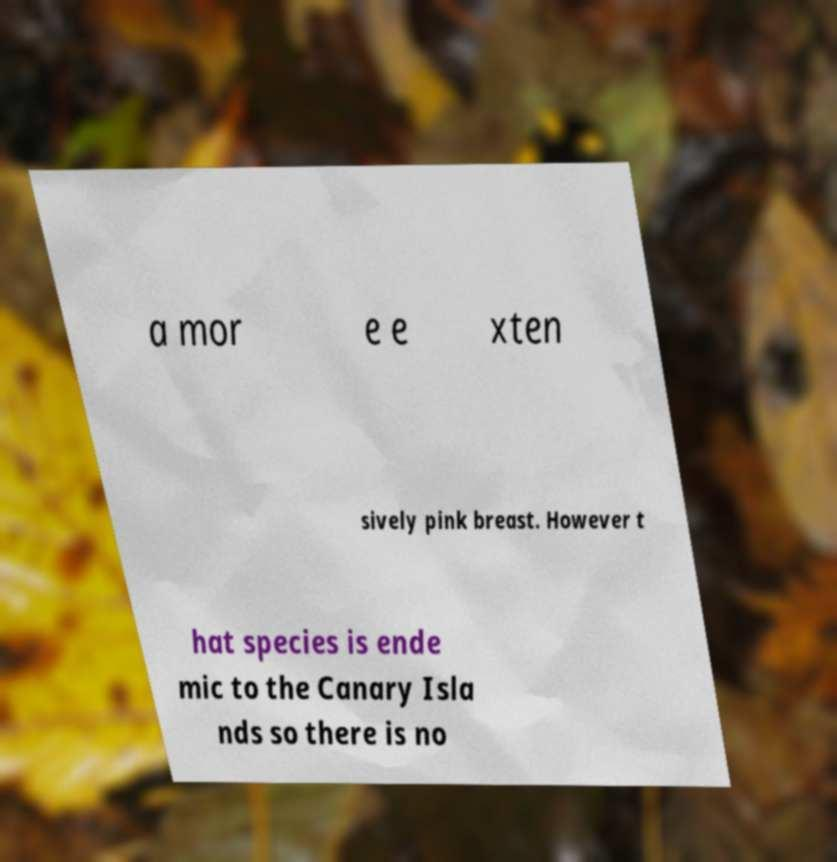Could you extract and type out the text from this image? a mor e e xten sively pink breast. However t hat species is ende mic to the Canary Isla nds so there is no 